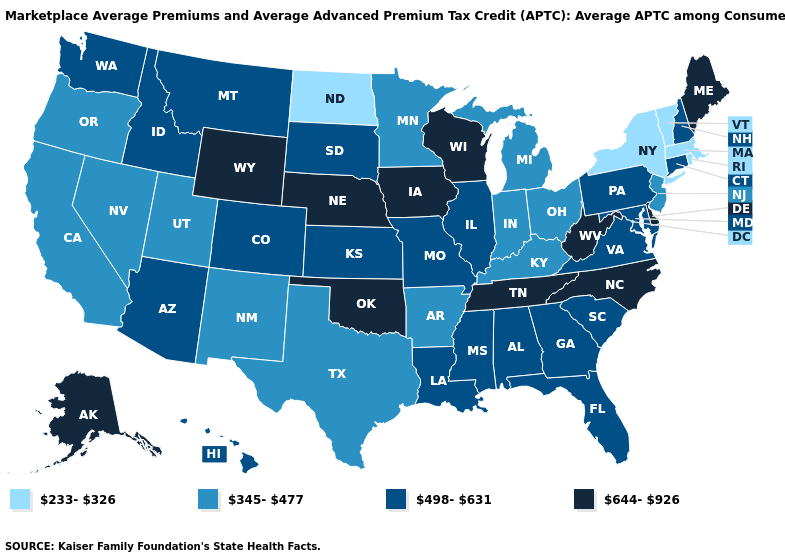What is the lowest value in states that border Florida?
Short answer required. 498-631. Does the map have missing data?
Be succinct. No. What is the value of North Carolina?
Quick response, please. 644-926. Name the states that have a value in the range 644-926?
Quick response, please. Alaska, Delaware, Iowa, Maine, Nebraska, North Carolina, Oklahoma, Tennessee, West Virginia, Wisconsin, Wyoming. Does New York have the lowest value in the USA?
Short answer required. Yes. What is the value of Maryland?
Be succinct. 498-631. Name the states that have a value in the range 233-326?
Be succinct. Massachusetts, New York, North Dakota, Rhode Island, Vermont. Which states hav the highest value in the West?
Keep it brief. Alaska, Wyoming. Name the states that have a value in the range 345-477?
Write a very short answer. Arkansas, California, Indiana, Kentucky, Michigan, Minnesota, Nevada, New Jersey, New Mexico, Ohio, Oregon, Texas, Utah. Which states have the lowest value in the USA?
Give a very brief answer. Massachusetts, New York, North Dakota, Rhode Island, Vermont. Does Mississippi have the highest value in the South?
Give a very brief answer. No. Name the states that have a value in the range 644-926?
Answer briefly. Alaska, Delaware, Iowa, Maine, Nebraska, North Carolina, Oklahoma, Tennessee, West Virginia, Wisconsin, Wyoming. Name the states that have a value in the range 345-477?
Answer briefly. Arkansas, California, Indiana, Kentucky, Michigan, Minnesota, Nevada, New Jersey, New Mexico, Ohio, Oregon, Texas, Utah. Does the map have missing data?
Quick response, please. No. Does Oregon have the same value as Colorado?
Be succinct. No. 